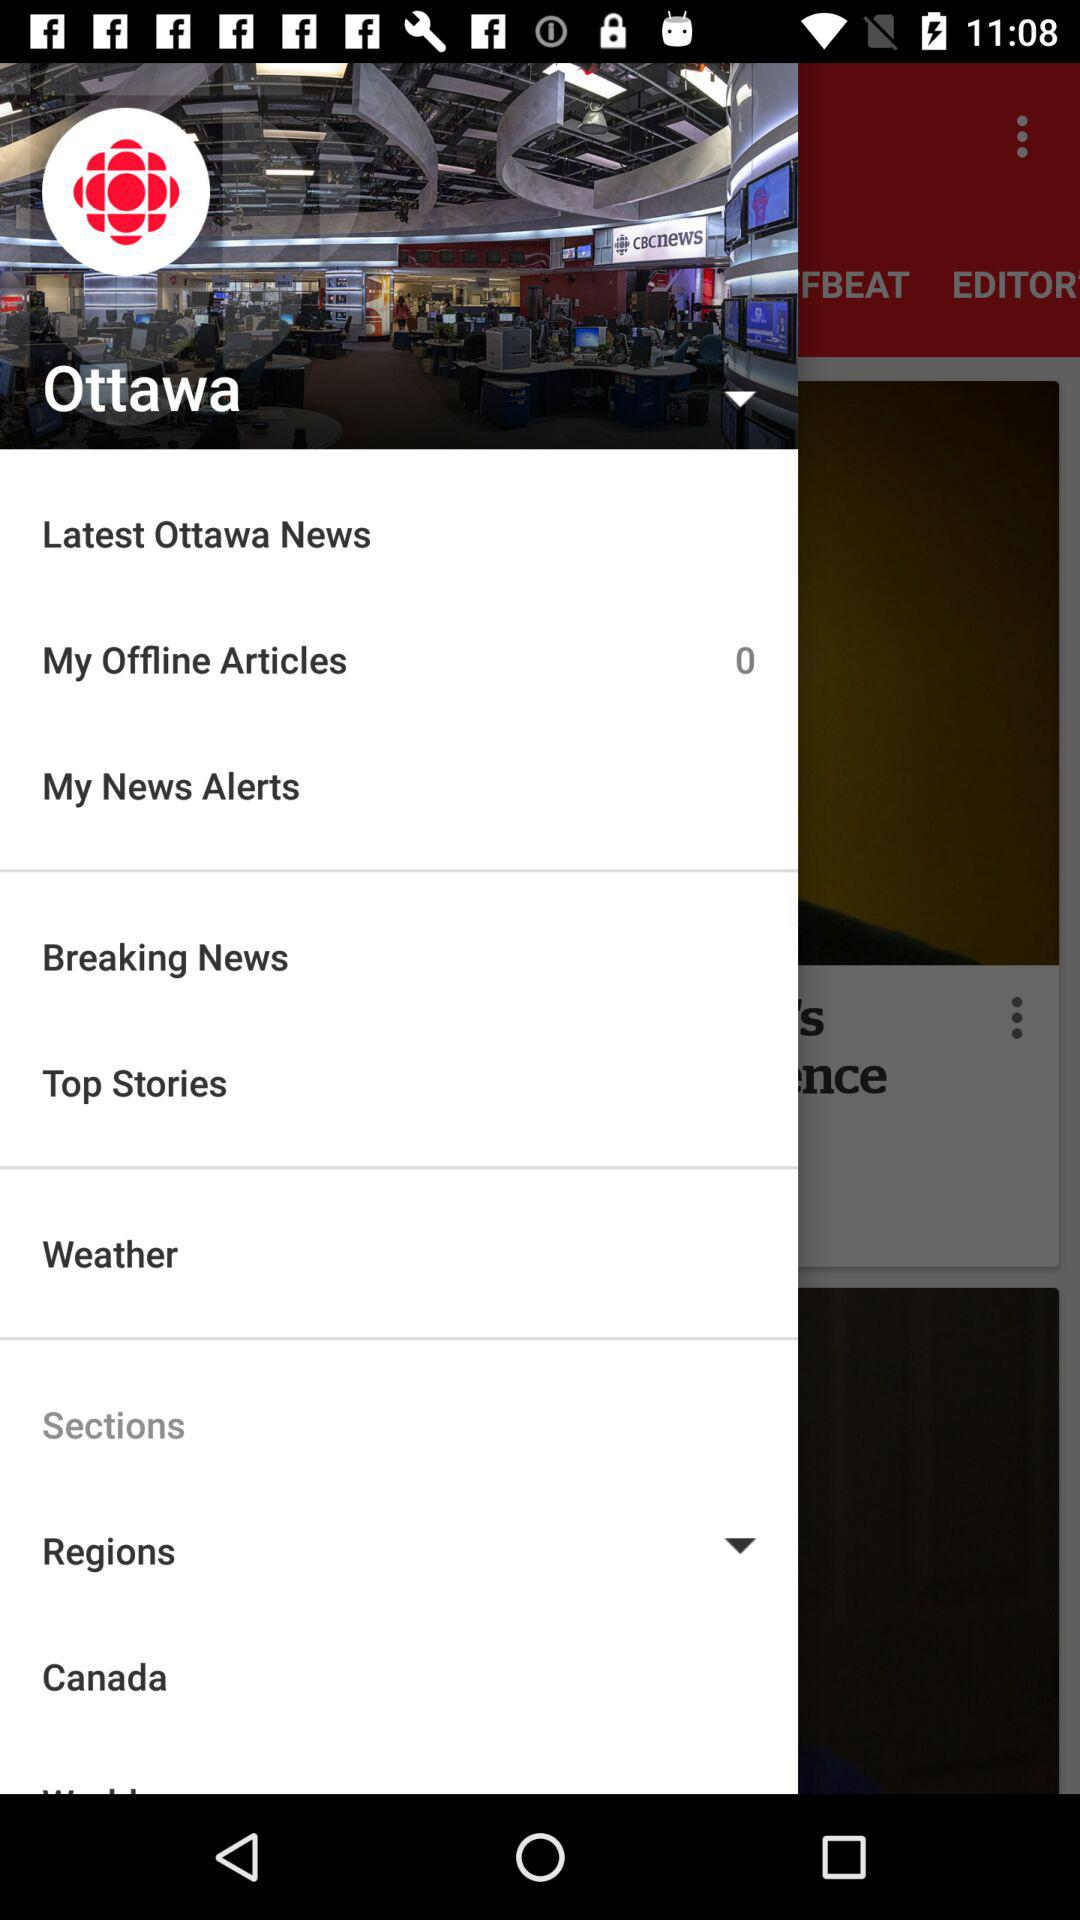Which region is selected? The selected region is Ottawa. 